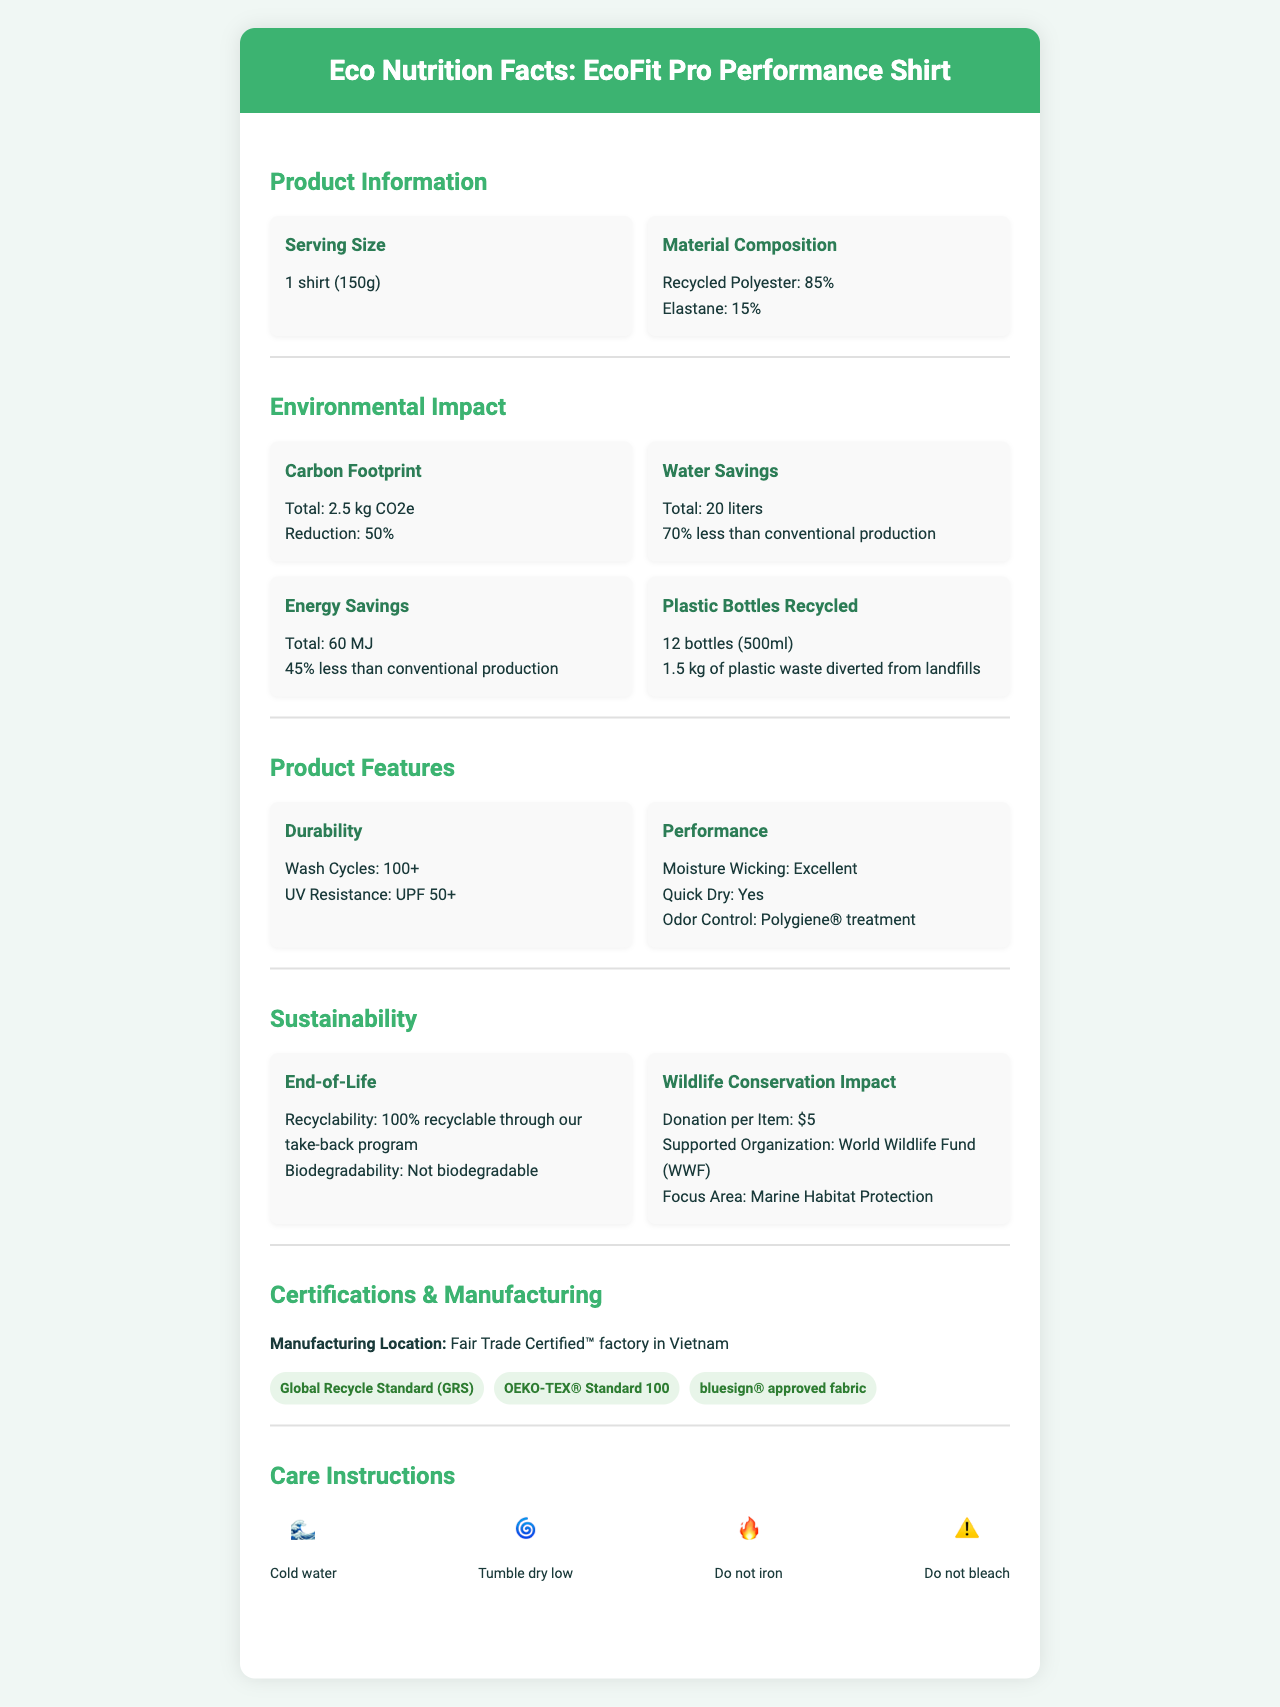what is the serving size of the EcoFit Pro Performance Shirt? The serving size is mentioned in the Product Information section as "1 shirt (150g)".
Answer: 1 shirt (150g) what is the percentage reduction in carbon footprint compared to virgin polyester? The Environmental Impact section under Carbon Footprint states a reduction of "50%".
Answer: 50% how much water is saved during the production of the EcoFit Pro Performance Shirt? The Water Savings information in the Environmental Impact section states "Total: 20 liters".
Answer: 20 liters list two features of the EcoFit Pro Performance Shirt related to its sustainability. The sustainability features mentioned include recyclability and the number of plastic bottles recycled.
Answer: 1. Recyclability: 100% recyclable through our take-back program 2. Plastic Bottles Recycled: 12 bottles (500ml) how many plastic bottles (500ml) are recycled to create one EcoFit Pro Performance Shirt? The Plastic Bottles Recycled information in the Environmental Impact section states "Amount: 12 bottles (500ml)".
Answer: 12 bottles which of these certifications does the EcoFit Pro Performance Shirt have? A. OEKO-TEX® Standard 100 B. Fair Trade Certified™ C. USDA Organic The Certifications section lists "OEKO-TEX® Standard 100", whereas Fair Trade Certified™ is the manufacturing location and USDA Organic is not mentioned.
Answer: A. OEKO-TEX® Standard 100 what is the energy savings percentage compared to conventional production? A. 30% B. 45% C. 60% D. 70% The Energy Savings information in the Environmental Impact section states "Percentage: 45% less than conventional production".
Answer: B. 45% does the EcoFit Pro Performance Shirt have odor control features? The Performance Features section states "Odor Control: Polygiene® treatment".
Answer: Yes is the EcoFit Pro Performance Shirt biodegradable? The End-of-Life information states "Biodegradability: Not biodegradable".
Answer: No summarize the main environmental benefits of the EcoFit Pro Performance Shirt. The summary captures the key environmental benefits highlighted in the Environmental Impact and Sustainability sections.
Answer: The EcoFit Pro Performance Shirt offers significant environmental benefits including a 50% reduction in carbon footprint compared to virgin polyester, 70% water savings, and 45% energy savings during production. It also recycles 12 plastic bottles per shirt and is 100% recyclable through a take-back program. why was this specific factory in Vietnam chosen for manufacturing the EcoFit Pro Performance Shirt? The document states that the shirt is manufactured in a Fair Trade Certified™ factory in Vietnam but does not provide reasons for choosing this specific factory.
Answer: Not enough information 